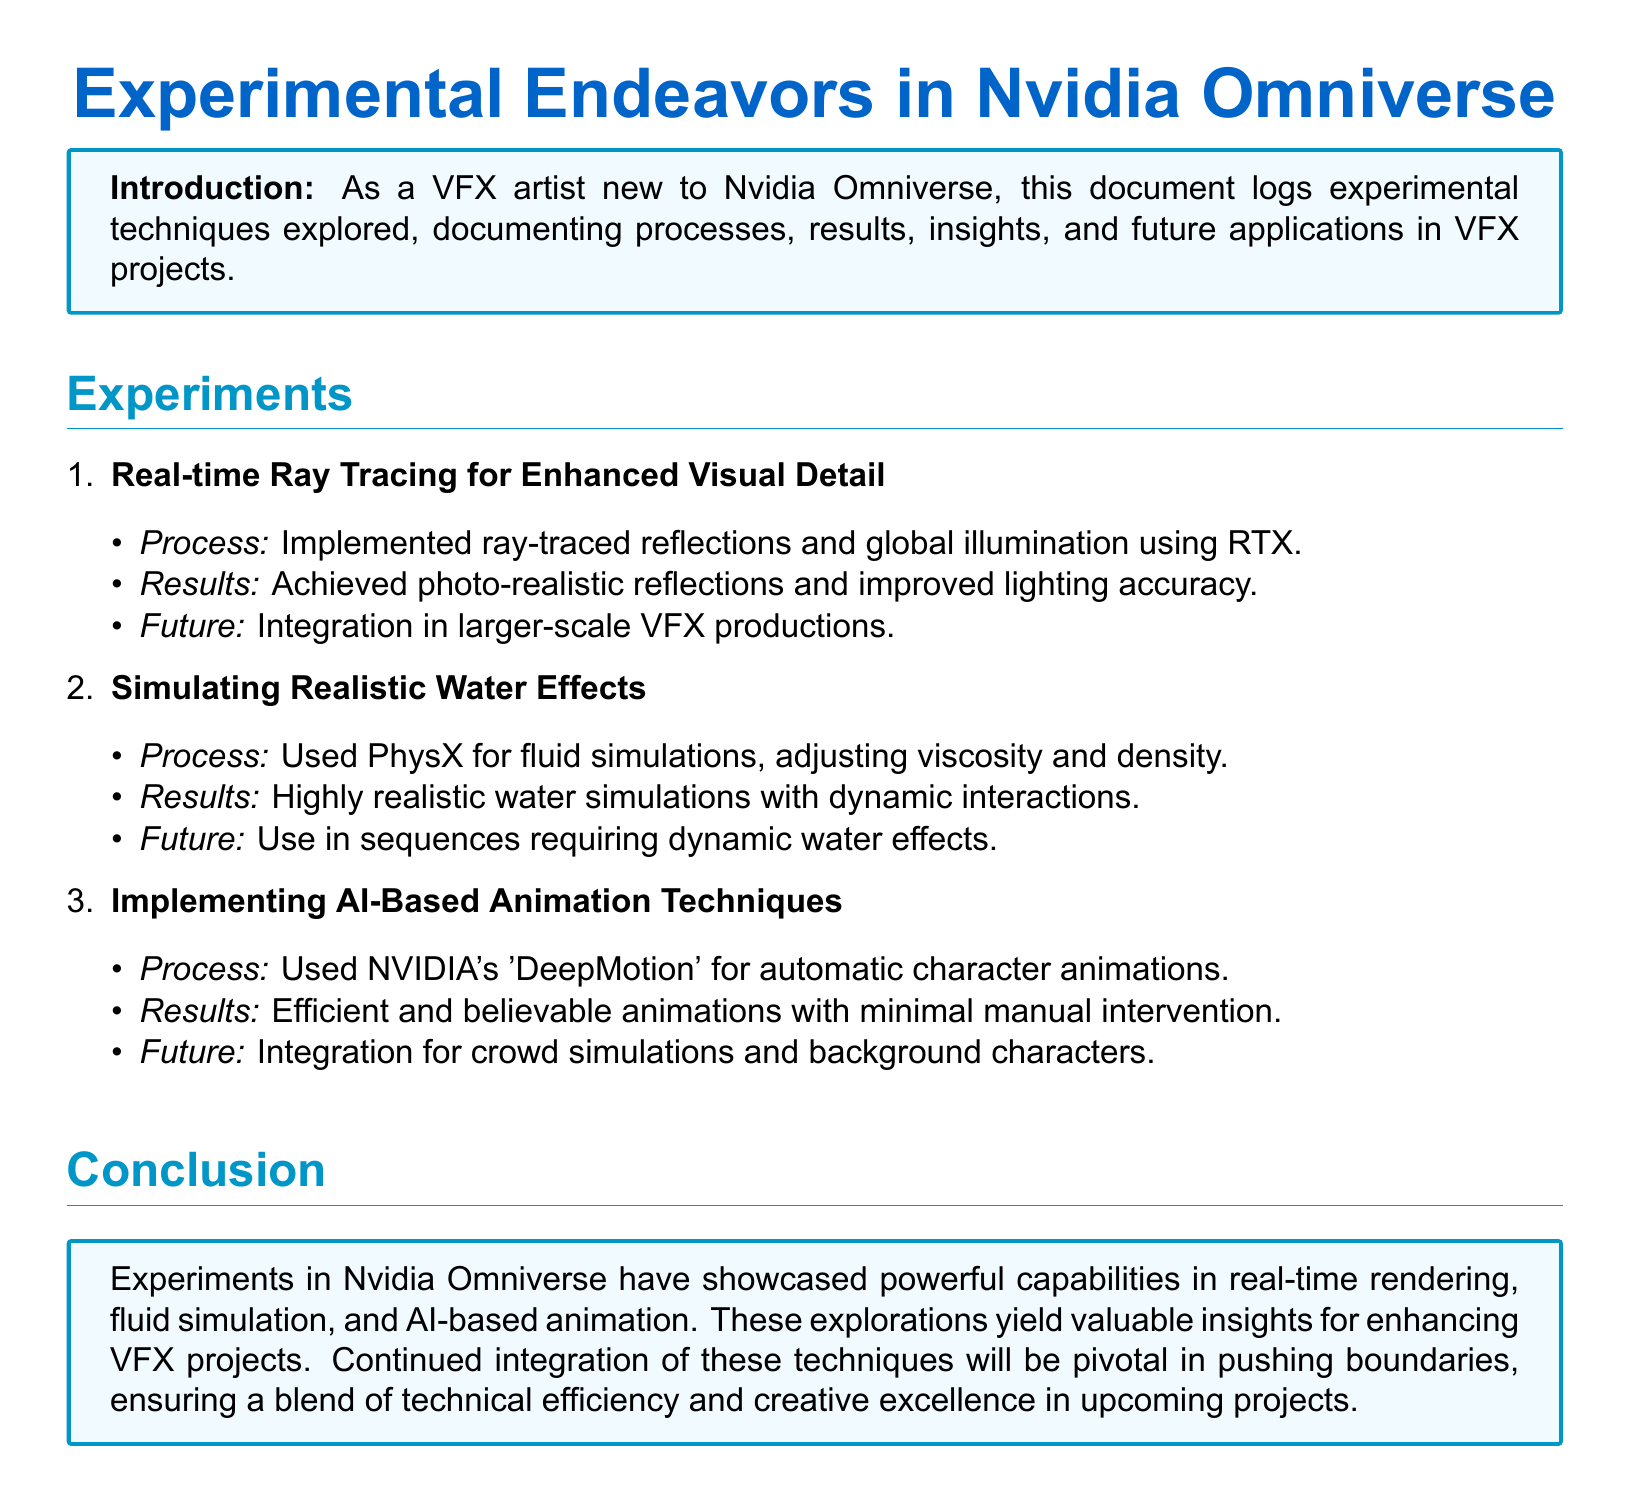what is the main topic of the document? The main topic is described in the title, which involves experimental endeavors in Nvidia Omniverse.
Answer: Experimental Endeavors in Nvidia Omniverse how many experiments are documented? The number of experiments is explicitly listed in the experiments section of the document.
Answer: Three what technique was used for realistic water simulations? The technique for water simulations is mentioned, highlighting the specific technology employed.
Answer: PhysX which NVIDIA tool is mentioned for AI-based animation? The specific NVIDIA tool used for AI-based animation is stated in the related experiment.
Answer: DeepMotion what is the future application for real-time ray tracing? The future application for the technique is provided in the results section under the corresponding experiment.
Answer: Larger-scale VFX productions what was the result of using NVIDIA's DeepMotion? The outcome of using the mentioned tool is explained in the context of the experiment results.
Answer: Efficient and believable animations what aspect of rendering does ray tracing enhance? The specific aspect that ray tracing improves is clearly stated in the results section of the document.
Answer: Visual detail what kind of simulations did the experiments aim to achieve? The type of simulations is specified in the introduction of the experiments section.
Answer: Realistic simulations 